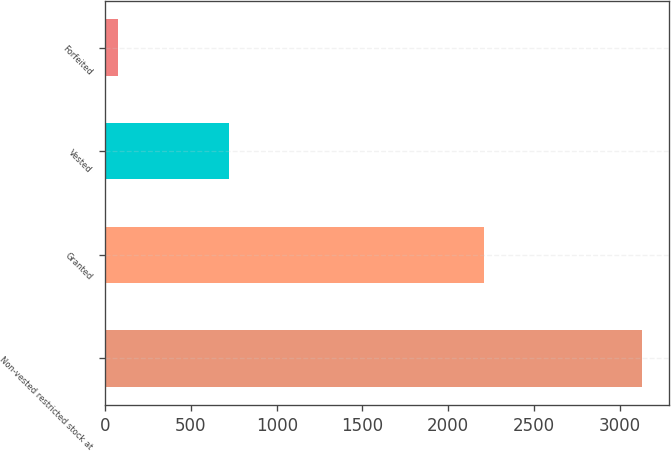<chart> <loc_0><loc_0><loc_500><loc_500><bar_chart><fcel>Non-vested restricted stock at<fcel>Granted<fcel>Vested<fcel>Forfeited<nl><fcel>3131<fcel>2207<fcel>723<fcel>73<nl></chart> 